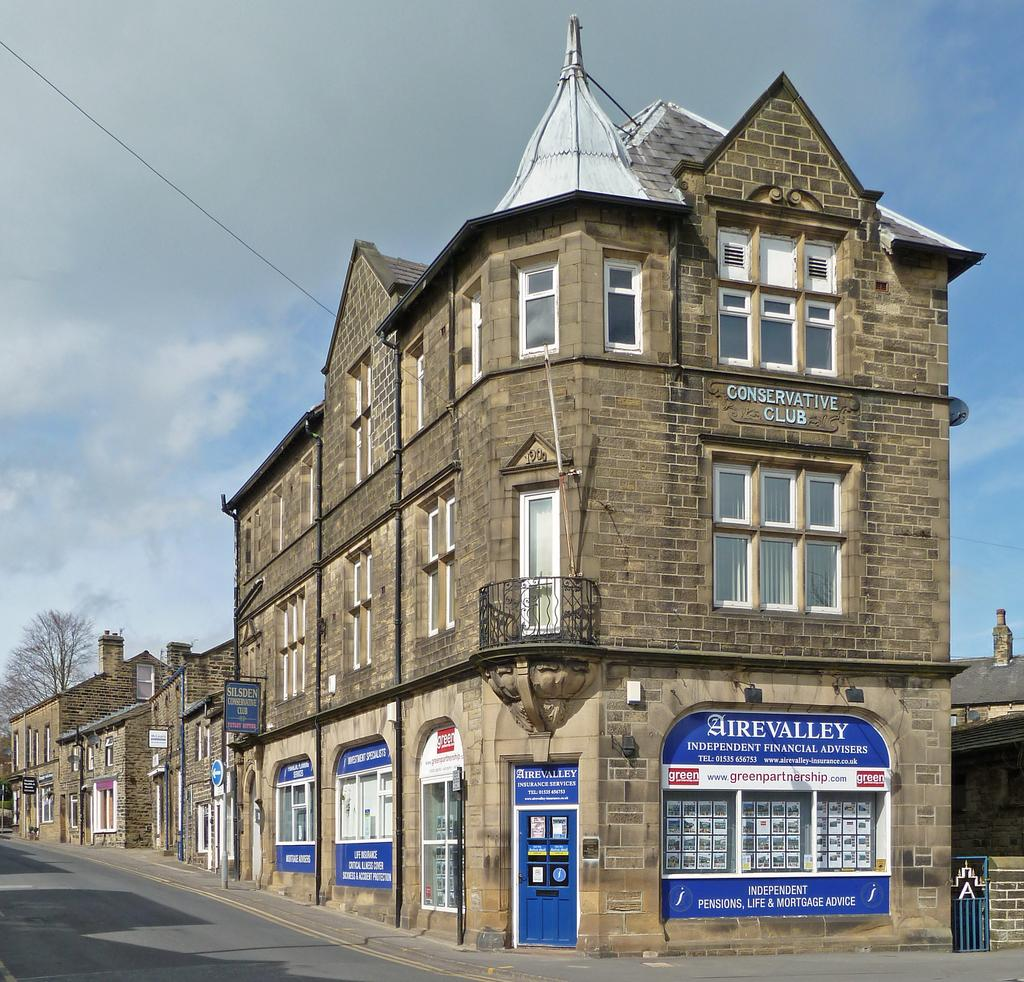What type of structures can be seen in the image? There are buildings in the image. How are the buildings positioned in relation to each other? The buildings are beside each other. What is in front of the buildings? There is a road in front of the buildings. What can be found on the footpath? There are poles and trees on the footpath. What is visible at the top of the image? The sky is visible at the top of the image. What direction is the aunt facing in the image? There is no aunt present in the image. What type of material is the rub made of in the image? There is no rub present in the image. 